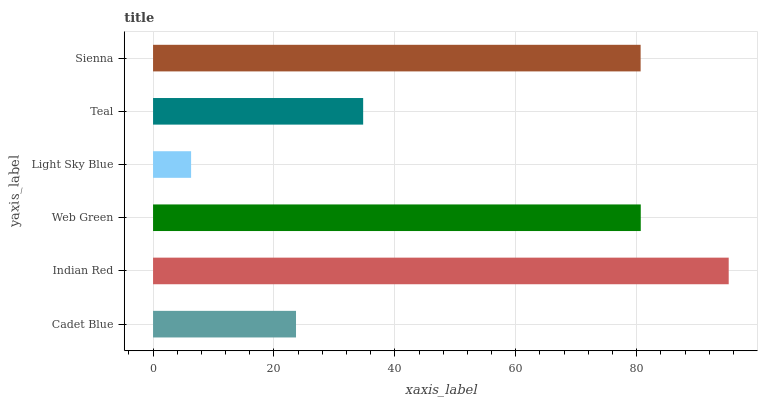Is Light Sky Blue the minimum?
Answer yes or no. Yes. Is Indian Red the maximum?
Answer yes or no. Yes. Is Web Green the minimum?
Answer yes or no. No. Is Web Green the maximum?
Answer yes or no. No. Is Indian Red greater than Web Green?
Answer yes or no. Yes. Is Web Green less than Indian Red?
Answer yes or no. Yes. Is Web Green greater than Indian Red?
Answer yes or no. No. Is Indian Red less than Web Green?
Answer yes or no. No. Is Sienna the high median?
Answer yes or no. Yes. Is Teal the low median?
Answer yes or no. Yes. Is Web Green the high median?
Answer yes or no. No. Is Light Sky Blue the low median?
Answer yes or no. No. 